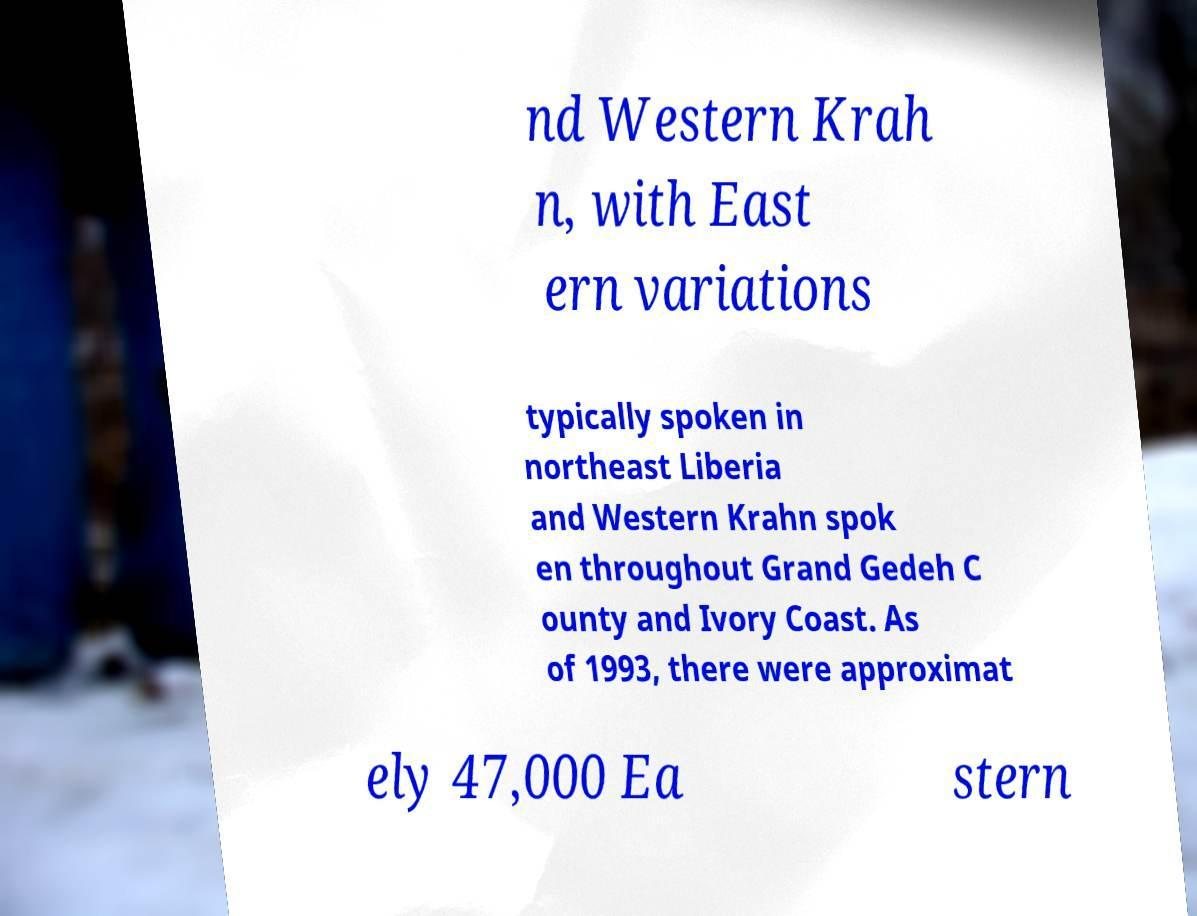Could you extract and type out the text from this image? nd Western Krah n, with East ern variations typically spoken in northeast Liberia and Western Krahn spok en throughout Grand Gedeh C ounty and Ivory Coast. As of 1993, there were approximat ely 47,000 Ea stern 